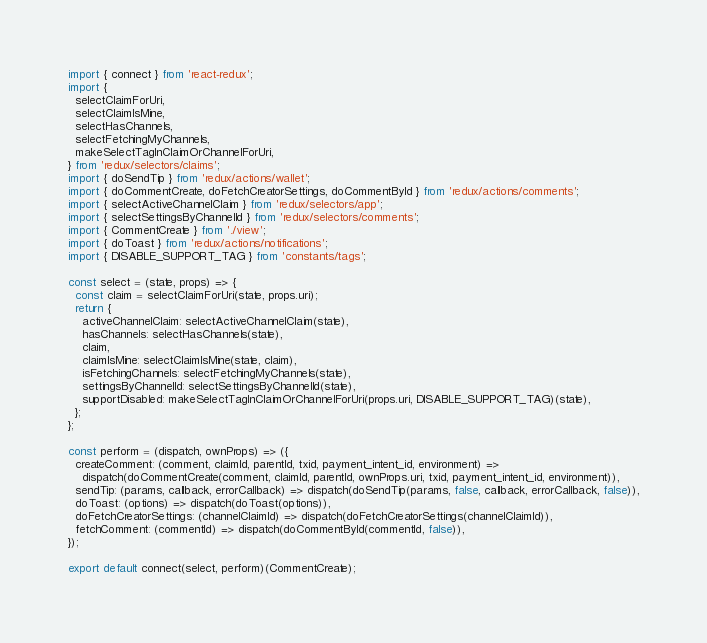<code> <loc_0><loc_0><loc_500><loc_500><_JavaScript_>import { connect } from 'react-redux';
import {
  selectClaimForUri,
  selectClaimIsMine,
  selectHasChannels,
  selectFetchingMyChannels,
  makeSelectTagInClaimOrChannelForUri,
} from 'redux/selectors/claims';
import { doSendTip } from 'redux/actions/wallet';
import { doCommentCreate, doFetchCreatorSettings, doCommentById } from 'redux/actions/comments';
import { selectActiveChannelClaim } from 'redux/selectors/app';
import { selectSettingsByChannelId } from 'redux/selectors/comments';
import { CommentCreate } from './view';
import { doToast } from 'redux/actions/notifications';
import { DISABLE_SUPPORT_TAG } from 'constants/tags';

const select = (state, props) => {
  const claim = selectClaimForUri(state, props.uri);
  return {
    activeChannelClaim: selectActiveChannelClaim(state),
    hasChannels: selectHasChannels(state),
    claim,
    claimIsMine: selectClaimIsMine(state, claim),
    isFetchingChannels: selectFetchingMyChannels(state),
    settingsByChannelId: selectSettingsByChannelId(state),
    supportDisabled: makeSelectTagInClaimOrChannelForUri(props.uri, DISABLE_SUPPORT_TAG)(state),
  };
};

const perform = (dispatch, ownProps) => ({
  createComment: (comment, claimId, parentId, txid, payment_intent_id, environment) =>
    dispatch(doCommentCreate(comment, claimId, parentId, ownProps.uri, txid, payment_intent_id, environment)),
  sendTip: (params, callback, errorCallback) => dispatch(doSendTip(params, false, callback, errorCallback, false)),
  doToast: (options) => dispatch(doToast(options)),
  doFetchCreatorSettings: (channelClaimId) => dispatch(doFetchCreatorSettings(channelClaimId)),
  fetchComment: (commentId) => dispatch(doCommentById(commentId, false)),
});

export default connect(select, perform)(CommentCreate);
</code> 